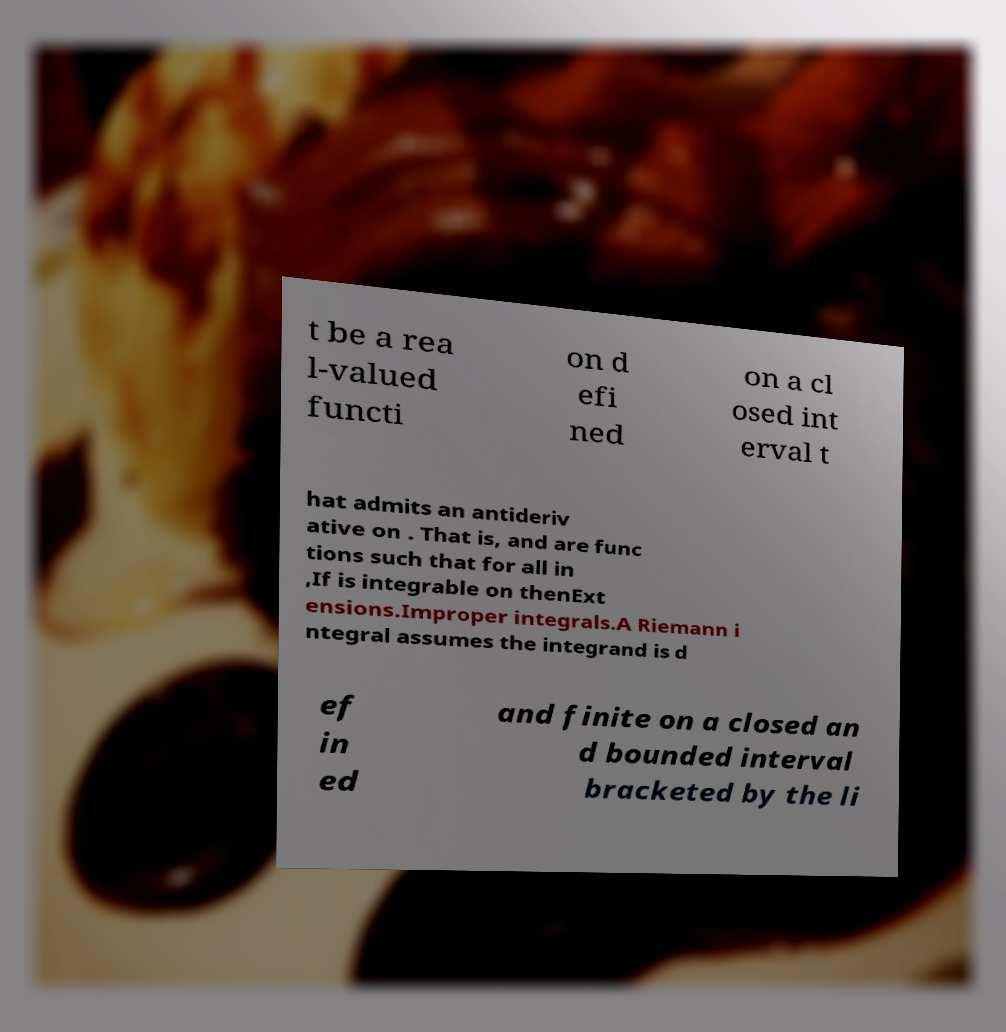Can you accurately transcribe the text from the provided image for me? t be a rea l-valued functi on d efi ned on a cl osed int erval t hat admits an antideriv ative on . That is, and are func tions such that for all in ,If is integrable on thenExt ensions.Improper integrals.A Riemann i ntegral assumes the integrand is d ef in ed and finite on a closed an d bounded interval bracketed by the li 